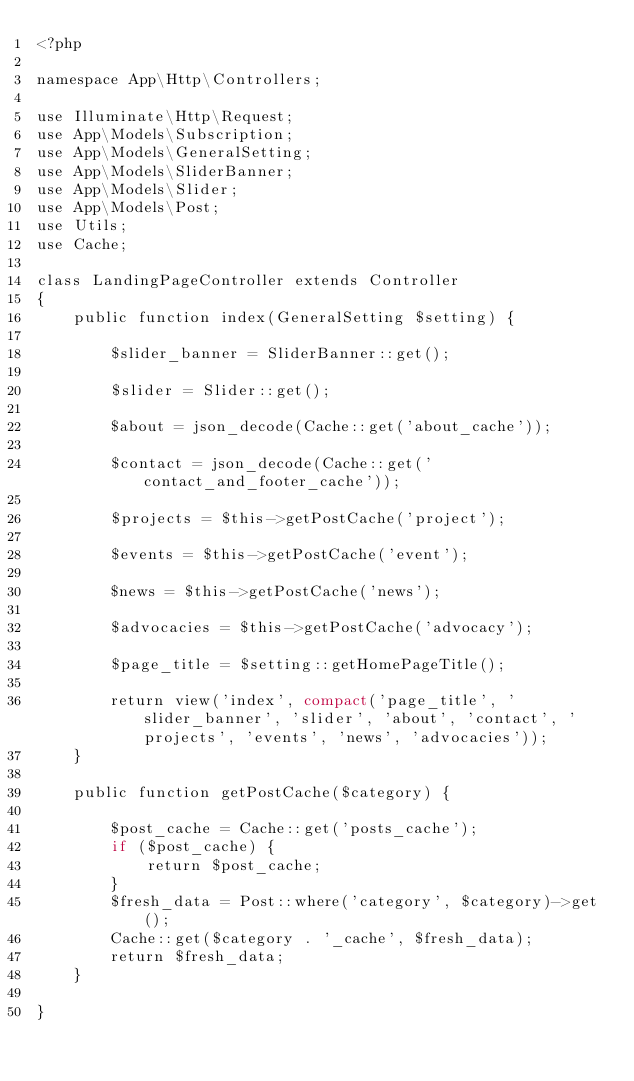<code> <loc_0><loc_0><loc_500><loc_500><_PHP_><?php

namespace App\Http\Controllers;

use Illuminate\Http\Request;
use App\Models\Subscription;
use App\Models\GeneralSetting;
use App\Models\SliderBanner;
use App\Models\Slider;
use App\Models\Post;
use Utils;
use Cache;

class LandingPageController extends Controller
{
    public function index(GeneralSetting $setting) {

        $slider_banner = SliderBanner::get();

        $slider = Slider::get();
        
        $about = json_decode(Cache::get('about_cache'));

        $contact = json_decode(Cache::get('contact_and_footer_cache'));

        $projects = $this->getPostCache('project');

        $events = $this->getPostCache('event');

        $news = $this->getPostCache('news');

        $advocacies = $this->getPostCache('advocacy');

        $page_title = $setting::getHomePageTitle();

        return view('index', compact('page_title', 'slider_banner', 'slider', 'about', 'contact', 'projects', 'events', 'news', 'advocacies'));
    }

    public function getPostCache($category) {
        
        $post_cache = Cache::get('posts_cache');
        if ($post_cache) {
            return $post_cache;
        }
        $fresh_data = Post::where('category', $category)->get();
        Cache::get($category . '_cache', $fresh_data);
        return $fresh_data;
    }

}
</code> 